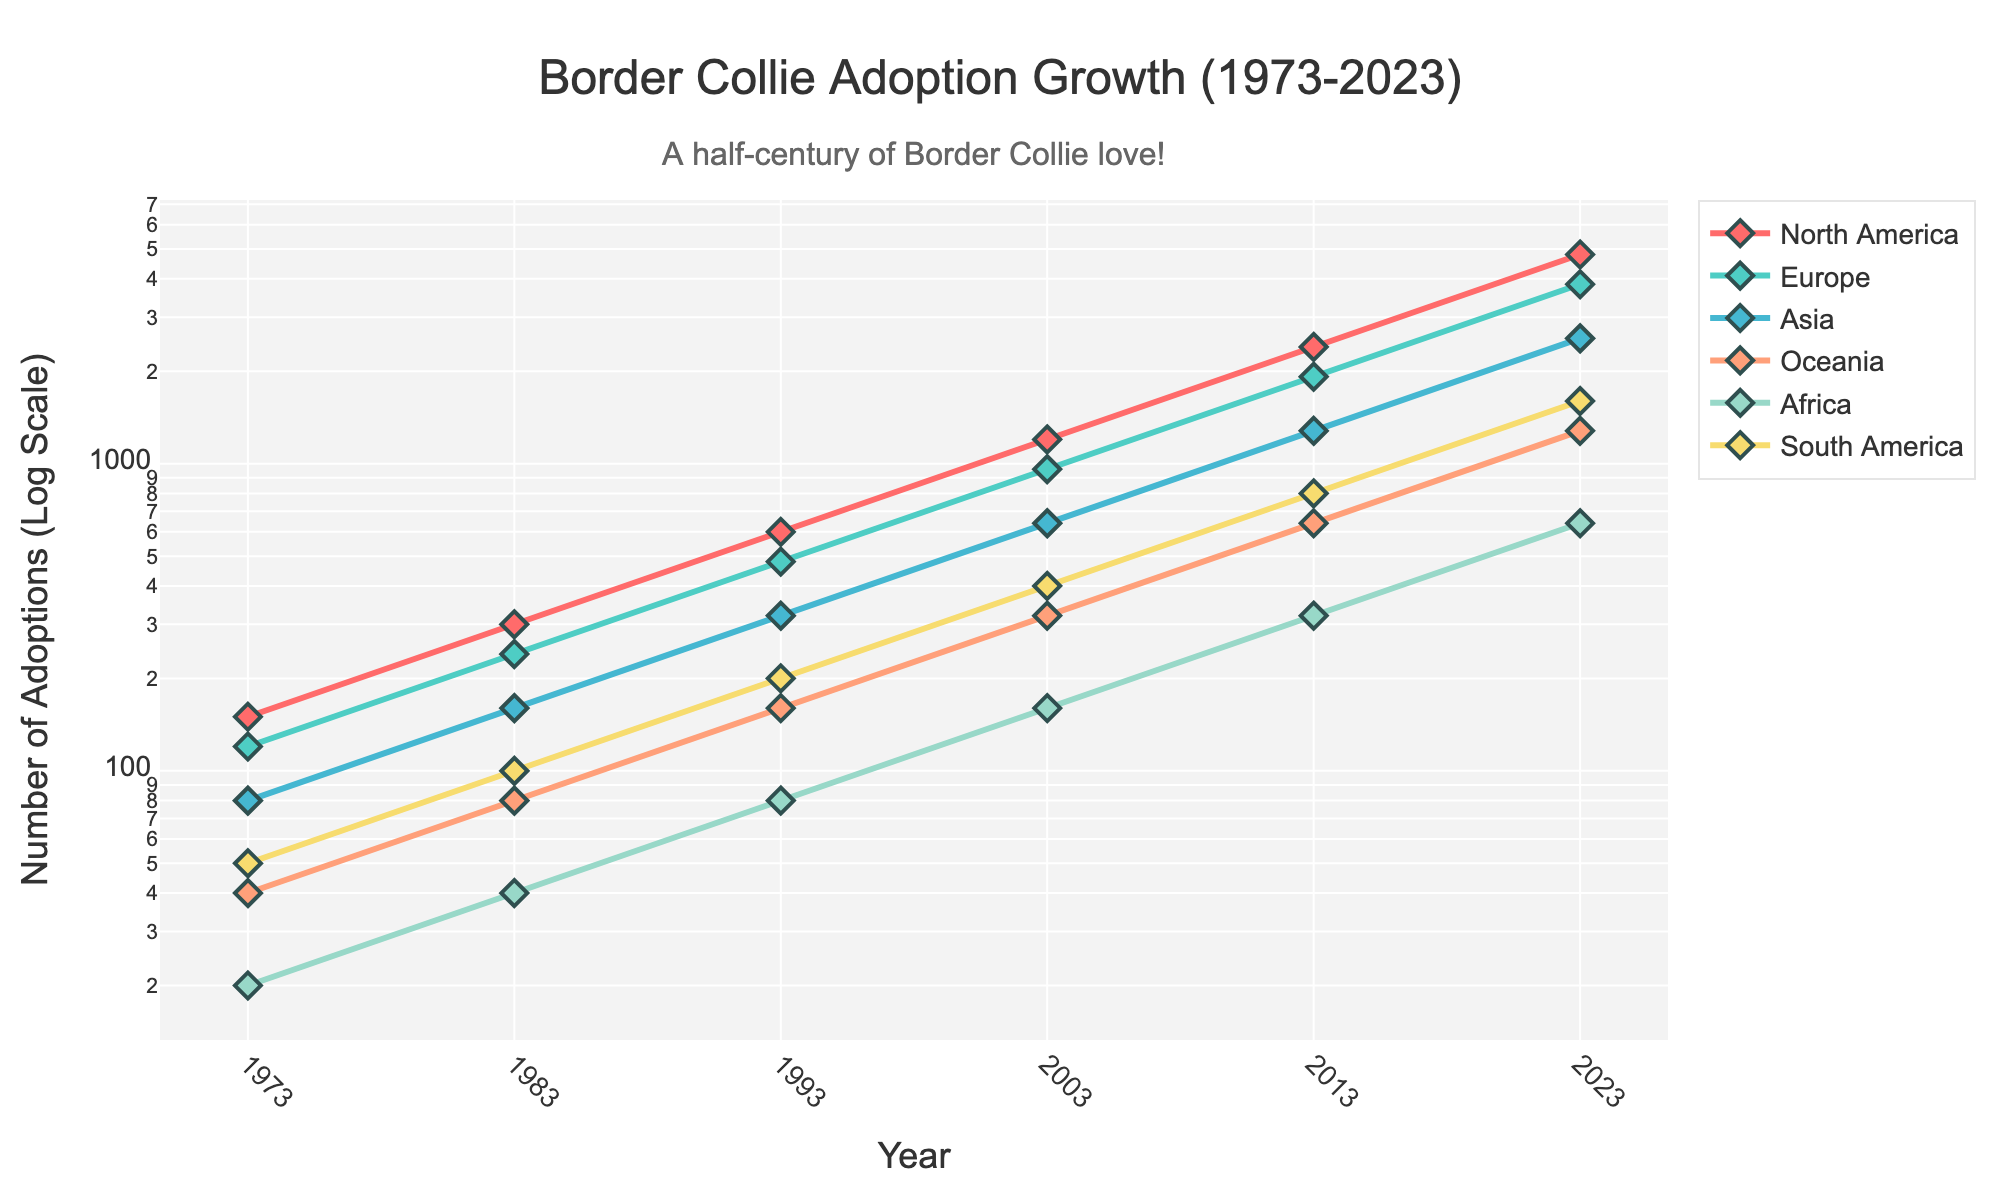What is the title of the plot? The title of the plot is displayed at the top of the figure.
Answer: Border Collie Adoption Growth (1973-2023) What is the y-axis scale used in the plot? The y-axis scale is specified in the y-axis title. It is a logarithmic scale.
Answer: Log Scale Which region had the highest number of adoptions in 2023? By looking at the data points for 2023, the colored line with the highest value on the y-axis represents the region with the highest number of adoptions.
Answer: North America How many data points are there for Europe? By counting the data points (markers) connected by lines for Europe across all years. Each year from 1973 to 2023 has one data point.
Answer: 6 Which region has the steepest growth rate in adoptions over the past 50 years? Identify the region whose line has the steepest upward trajectory from 1973 to 2023 by comparing the slopes of the lines visually.
Answer: North America What are the adoption numbers for North America in 1993? Find the data point for North America in the year 1993 on the plot.
Answer: 600 What is the average number of adoptions for Asia from 1973 to 2023? Sum the adoption numbers for Asia across all the years, and divide by the total number of years (6). (80+160+320+640+1280+2560)/6 = 673.33
Answer: 673.33 How does the number of adoptions in Oceania in 2013 compare to that in 1973? Check the adoption numbers for Oceania in both 2013 and 1973, and calculate the ratio between these two values. (640/40 = 16)
Answer: 16 times higher Which two regions showed similar adoption trends? Look for regions whose lines have parallel trajectories or similar slopes over the years.
Answer: Europe and Asia Compare the growth rate in adoptions between Africa and South America from 1973 to 2023. Calculate the difference in the starting and ending values for both regions and determine the ratio of growth. Africa: (640/20)=32, South America: (1600/50)=32. Both regions have the same ratio indicating similar growth rates.
Answer: Similar 